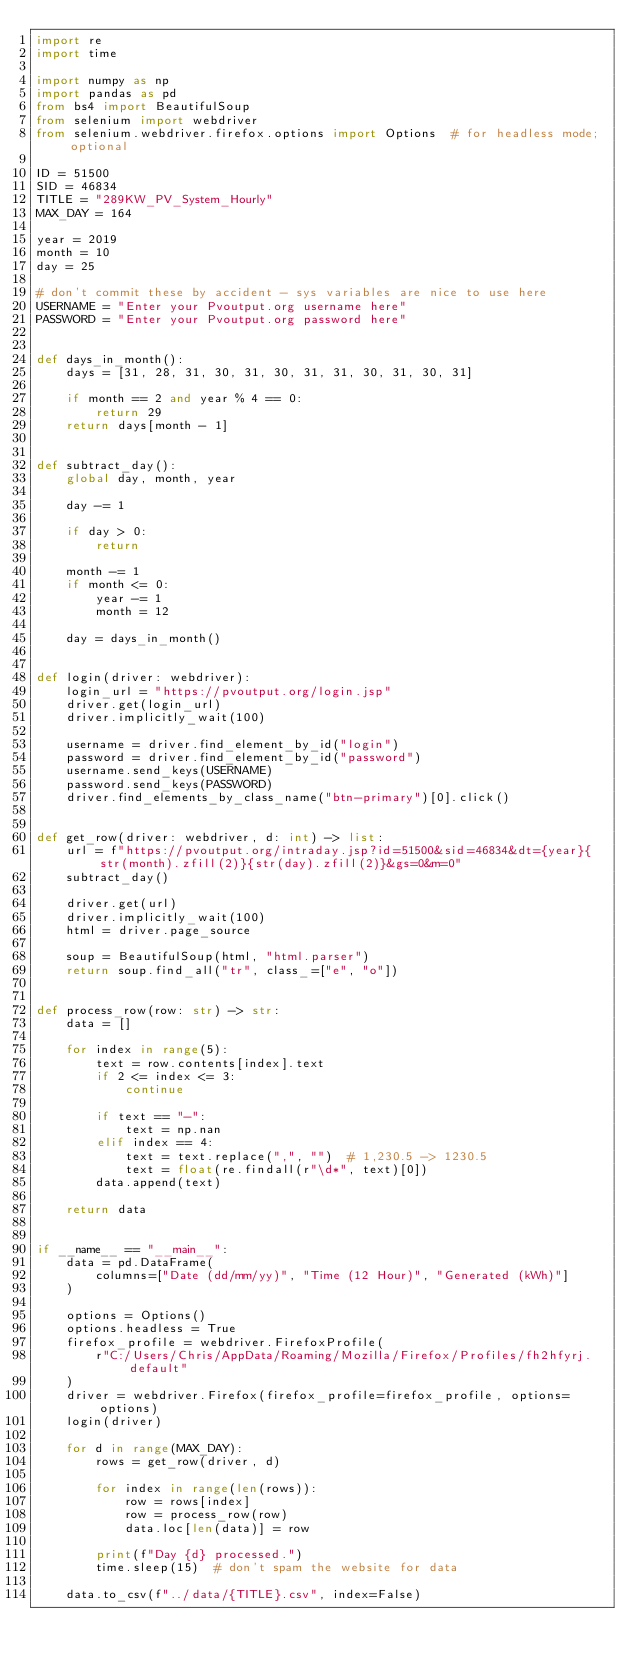Convert code to text. <code><loc_0><loc_0><loc_500><loc_500><_Python_>import re
import time

import numpy as np
import pandas as pd
from bs4 import BeautifulSoup
from selenium import webdriver
from selenium.webdriver.firefox.options import Options  # for headless mode; optional

ID = 51500
SID = 46834
TITLE = "289KW_PV_System_Hourly"
MAX_DAY = 164

year = 2019
month = 10
day = 25

# don't commit these by accident - sys variables are nice to use here
USERNAME = "Enter your Pvoutput.org username here"
PASSWORD = "Enter your Pvoutput.org password here"


def days_in_month():
    days = [31, 28, 31, 30, 31, 30, 31, 31, 30, 31, 30, 31]

    if month == 2 and year % 4 == 0:
        return 29
    return days[month - 1]


def subtract_day():
    global day, month, year

    day -= 1

    if day > 0:
        return

    month -= 1
    if month <= 0:
        year -= 1
        month = 12

    day = days_in_month()


def login(driver: webdriver):
    login_url = "https://pvoutput.org/login.jsp"
    driver.get(login_url)
    driver.implicitly_wait(100)

    username = driver.find_element_by_id("login")
    password = driver.find_element_by_id("password")
    username.send_keys(USERNAME)
    password.send_keys(PASSWORD)
    driver.find_elements_by_class_name("btn-primary")[0].click()


def get_row(driver: webdriver, d: int) -> list:
    url = f"https://pvoutput.org/intraday.jsp?id=51500&sid=46834&dt={year}{str(month).zfill(2)}{str(day).zfill(2)}&gs=0&m=0"
    subtract_day()

    driver.get(url)
    driver.implicitly_wait(100)
    html = driver.page_source

    soup = BeautifulSoup(html, "html.parser")
    return soup.find_all("tr", class_=["e", "o"])


def process_row(row: str) -> str:
    data = []

    for index in range(5):
        text = row.contents[index].text
        if 2 <= index <= 3:
            continue

        if text == "-":
            text = np.nan
        elif index == 4:
            text = text.replace(",", "")  # 1,230.5 -> 1230.5
            text = float(re.findall(r"\d*", text)[0])
        data.append(text)

    return data


if __name__ == "__main__":
    data = pd.DataFrame(
        columns=["Date (dd/mm/yy)", "Time (12 Hour)", "Generated (kWh)"]
    )

    options = Options()
    options.headless = True
    firefox_profile = webdriver.FirefoxProfile(
        r"C:/Users/Chris/AppData/Roaming/Mozilla/Firefox/Profiles/fh2hfyrj.default"
    )
    driver = webdriver.Firefox(firefox_profile=firefox_profile, options=options)
    login(driver)

    for d in range(MAX_DAY):
        rows = get_row(driver, d)

        for index in range(len(rows)):
            row = rows[index]
            row = process_row(row)
            data.loc[len(data)] = row

        print(f"Day {d} processed.")
        time.sleep(15)  # don't spam the website for data

    data.to_csv(f"../data/{TITLE}.csv", index=False)
</code> 